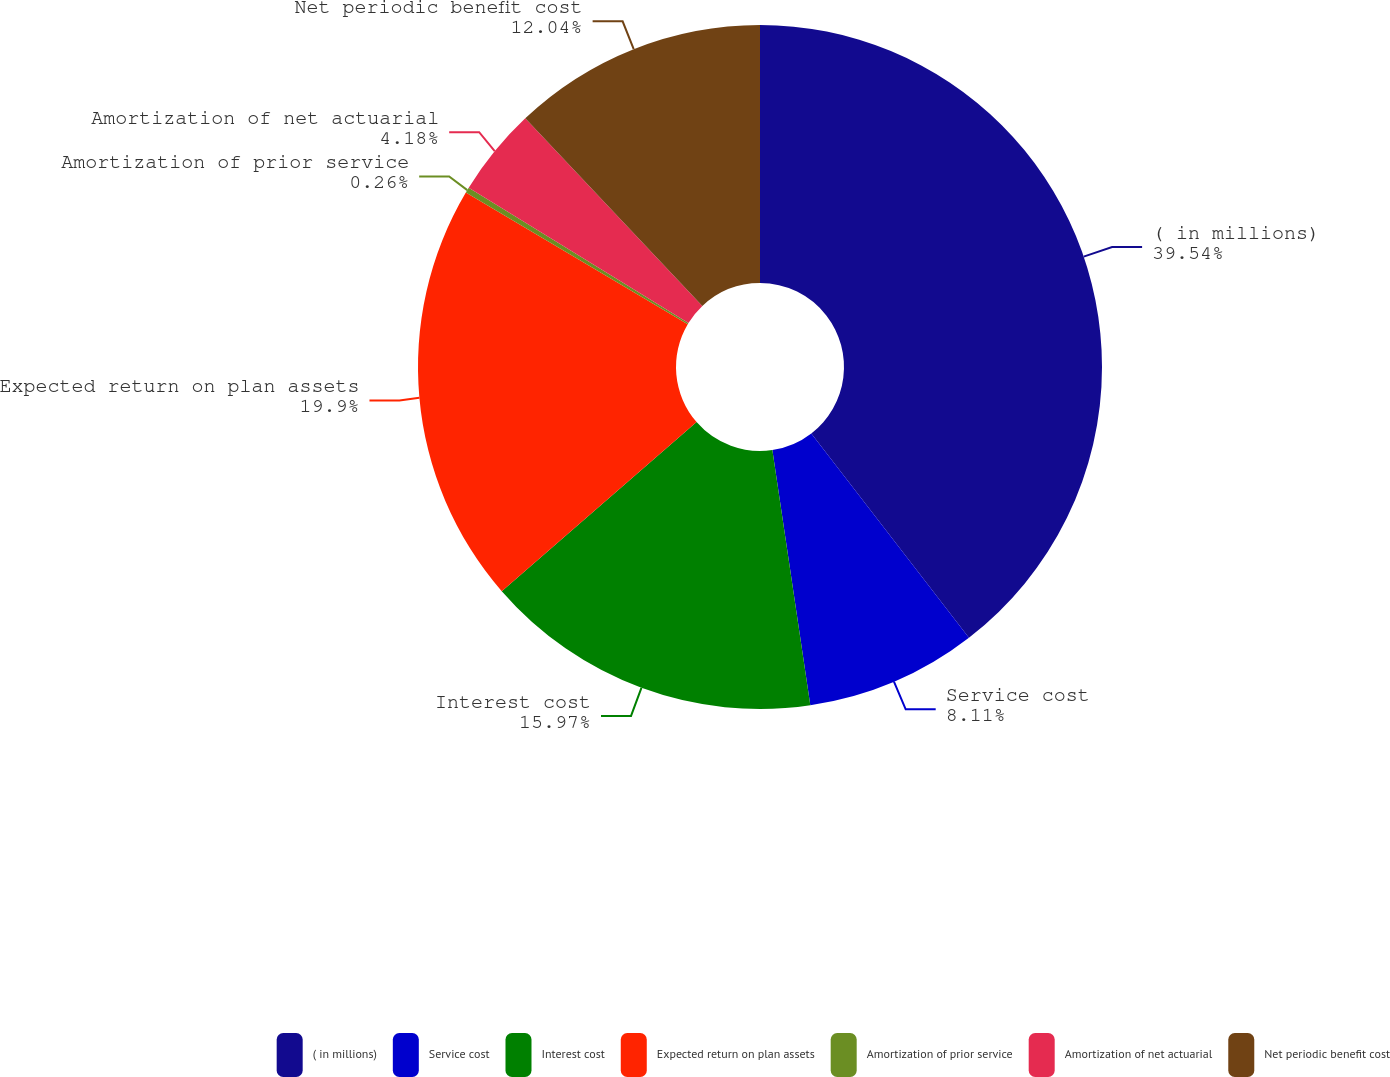<chart> <loc_0><loc_0><loc_500><loc_500><pie_chart><fcel>( in millions)<fcel>Service cost<fcel>Interest cost<fcel>Expected return on plan assets<fcel>Amortization of prior service<fcel>Amortization of net actuarial<fcel>Net periodic benefit cost<nl><fcel>39.54%<fcel>8.11%<fcel>15.97%<fcel>19.9%<fcel>0.26%<fcel>4.18%<fcel>12.04%<nl></chart> 